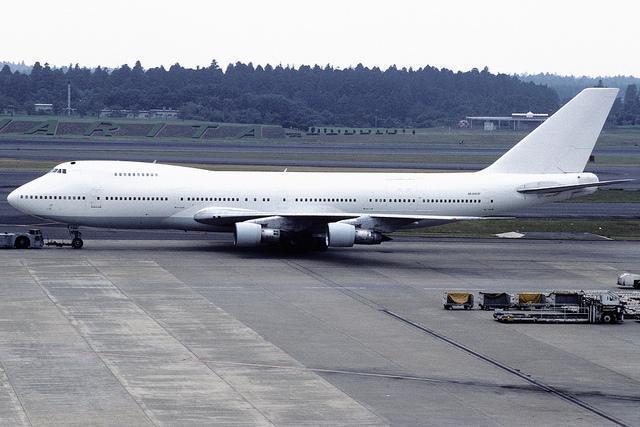Why is there no logo on the plane?
Pick the correct solution from the four options below to address the question.
Options: No money, not finished, other side, secret. Not finished. 